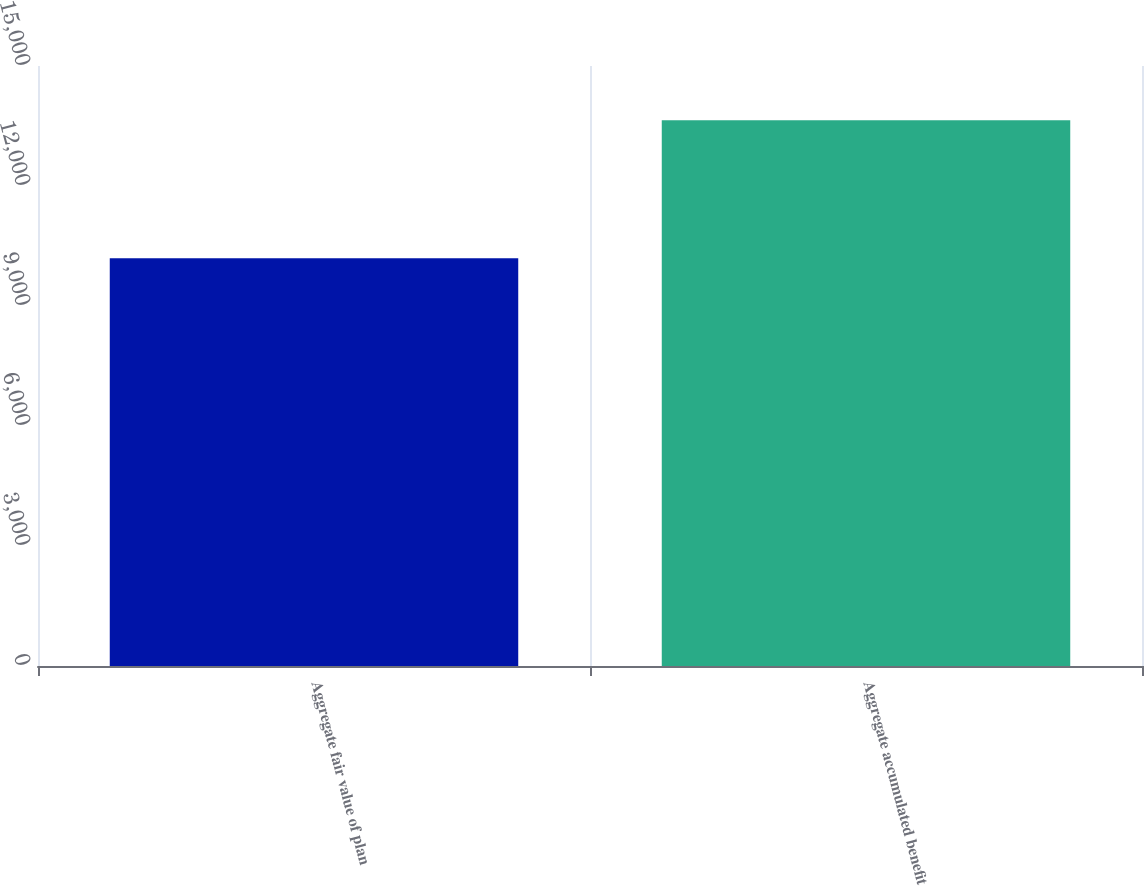Convert chart to OTSL. <chart><loc_0><loc_0><loc_500><loc_500><bar_chart><fcel>Aggregate fair value of plan<fcel>Aggregate accumulated benefit<nl><fcel>10193<fcel>13645<nl></chart> 